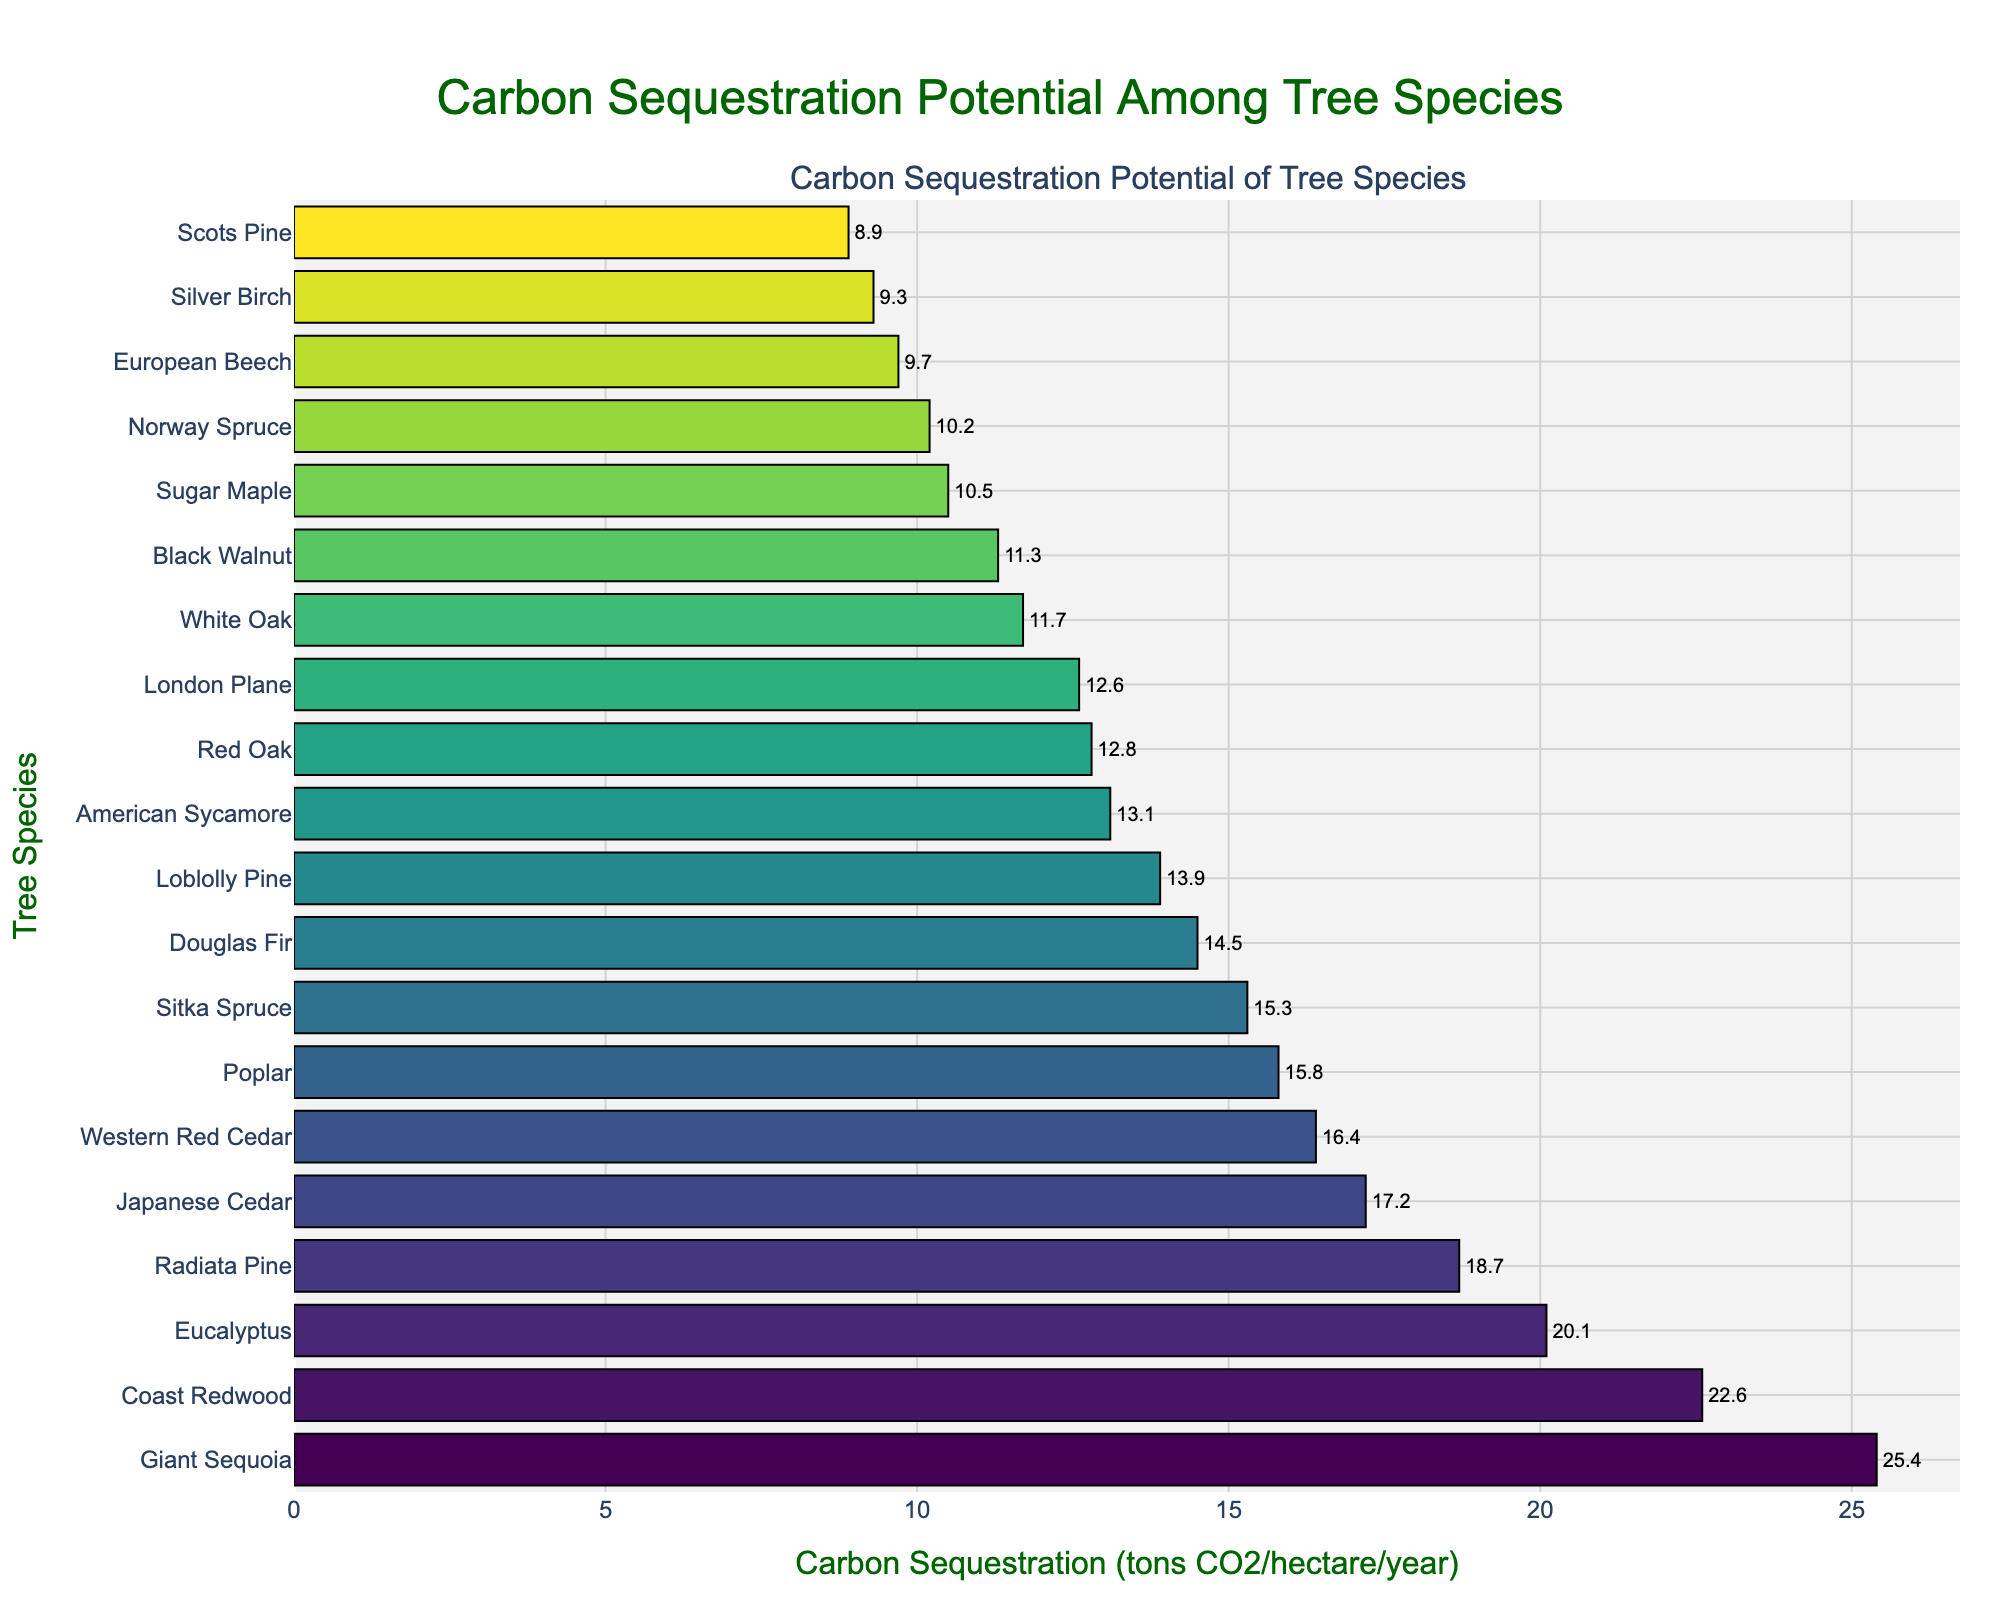Which tree species has the highest carbon sequestration potential? Observing the bar chart, the tree species with the longest bar corresponds to the highest value. The Giant Sequoia's bar is the longest on the chart, indicating it has the highest carbon sequestration potential.
Answer: Giant Sequoia Which tree species has the lowest carbon sequestration potential? The species with the shortest bar represents the lowest value. In the bar chart, Scots Pine has the shortest bar, indicating the lowest carbon sequestration potential.
Answer: Scots Pine What is the carbon sequestration potential of the Coast Redwood compared to the Radiata Pine? Find the bars corresponding to Coast Redwood and Radiata Pine. Coast Redwood has a value of 22.6 tons CO2/hectare/year, while Radiata Pine has 18.7 tons CO2/hectare/year.
Answer: Coast Redwood: 22.6, Radiata Pine: 18.7 How much more CO2 does Giant Sequoia sequester compared to Norway Spruce? Check the values for Giant Sequoia and Norway Spruce from the chart. Giant Sequoia is 25.4, and Norway Spruce is 10.2. Subtract Norway Spruce from Giant Sequoia: 25.4 - 10.2.
Answer: 15.2 tons CO2/hectare/year What is the average carbon sequestration potential of Douglas Fir, Eucalyptus, and Radiata Pine? Find the values of Douglas Fir (14.5), Eucalyptus (20.1), and Radiata Pine (18.7). Sum these values and divide by 3: (14.5 + 20.1 + 18.7) / 3.
Answer: 17.8 tons CO2/hectare/year Are there any tree species with the same carbon sequestration potential? Examine the bars and check for identical lengths. In this chart, no two tree species have the same carbon sequestration potential.
Answer: No Which tree species has a carbon sequestration potential closest to 15 tons CO2/hectare/year? Identify the tree species whose bar length represents a value closest to 15. Poplar (15.8) and Sitka Spruce (15.3) are closest to 15. The closest is Sitka Spruce.
Answer: Sitka Spruce How does the carbon sequestration potential of European Beech compare to that of Silver Birch? Find the values for European Beech (9.7) and Silver Birch (9.3). European Beech has a slightly higher value than Silver Birch.
Answer: European Beech: 9.7, Silver Birch: 9.3 What is the range of carbon sequestration potentials among the tree species? The range is the difference between the maximum and minimum values. Maximum value is Giant Sequoia (25.4), and minimum is Scots Pine (8.9). Subtract the minimum from the maximum: 25.4 - 8.9.
Answer: 16.5 tons CO2/hectare/year Which tree species have a carbon sequestration potential higher than 20 tons CO2/hectare/year? Identify all species with bars longer than the 20 ton mark. The species are Eucalyptus (20.1), Coast Redwood (22.6), and Giant Sequoia (25.4).
Answer: Eucalyptus, Coast Redwood, Giant Sequoia 